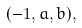<formula> <loc_0><loc_0><loc_500><loc_500>( - 1 , a , b ) ,</formula> 